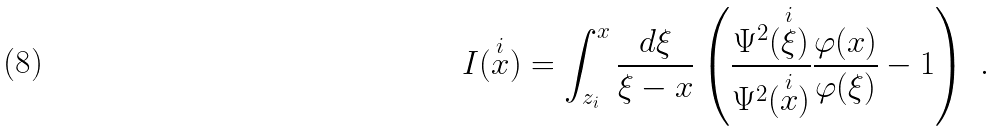Convert formula to latex. <formula><loc_0><loc_0><loc_500><loc_500>I ( \overset { i } { x } ) = \int _ { z _ { i } } ^ { x } \frac { d \xi } { \xi - x } \left ( \frac { \Psi ^ { 2 } ( \overset { i } { \xi } ) } { \Psi ^ { 2 } ( \overset { i } { x } ) } \frac { \varphi ( x ) } { \varphi ( \xi ) } - 1 \right ) \ .</formula> 